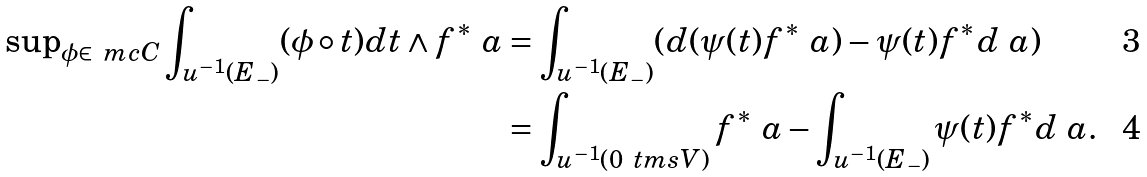Convert formula to latex. <formula><loc_0><loc_0><loc_500><loc_500>\text {sup} _ { \phi \in \ m c { C } } \int _ { u ^ { - 1 } ( E _ { - } ) } ( \phi \circ t ) d t \wedge f ^ { * } \ a & = \int _ { u ^ { - 1 } ( E _ { - } ) } ( d ( \psi ( t ) f ^ { * } \ a ) - \psi ( t ) f ^ { * } d \ a ) \\ & = \int _ { u ^ { - 1 } ( 0 \ t m s V ) } f ^ { * } \ a - \int _ { u ^ { - 1 } ( E _ { - } ) } \psi ( t ) f ^ { * } d \ a .</formula> 